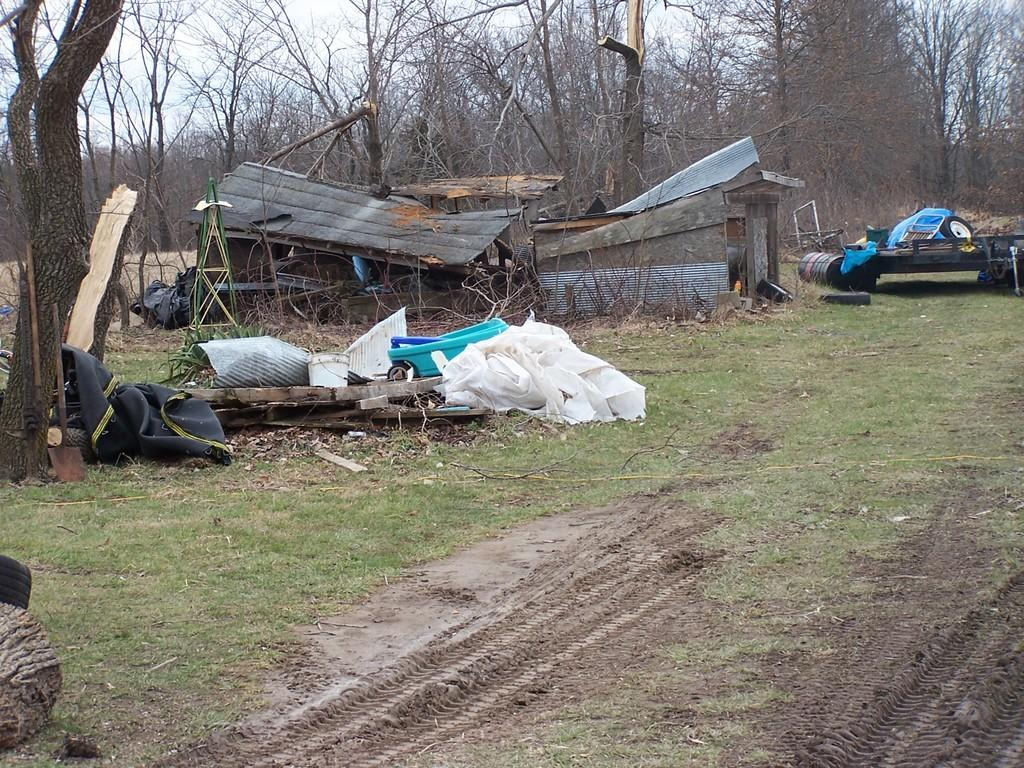What is the main subject of the image? The main subject of the image is a destroyed house. What can be seen in the image besides the destroyed house? There is white color cloth, grass on the ground, trees in the background, and the sky visible in the background. What type of joke can be seen on the moon in the image? There is no moon present in the image, and therefore no joke can be seen on it. 